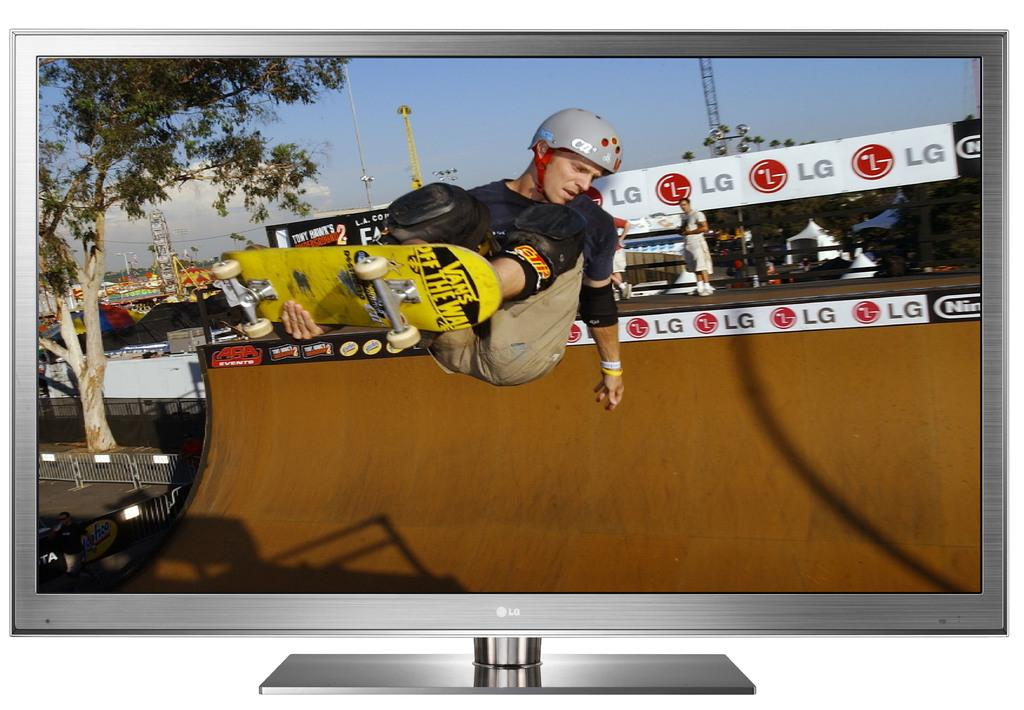<image>
Write a terse but informative summary of the picture. Tony hawk riding a vans branded skate board wit han LG adver in the back. 